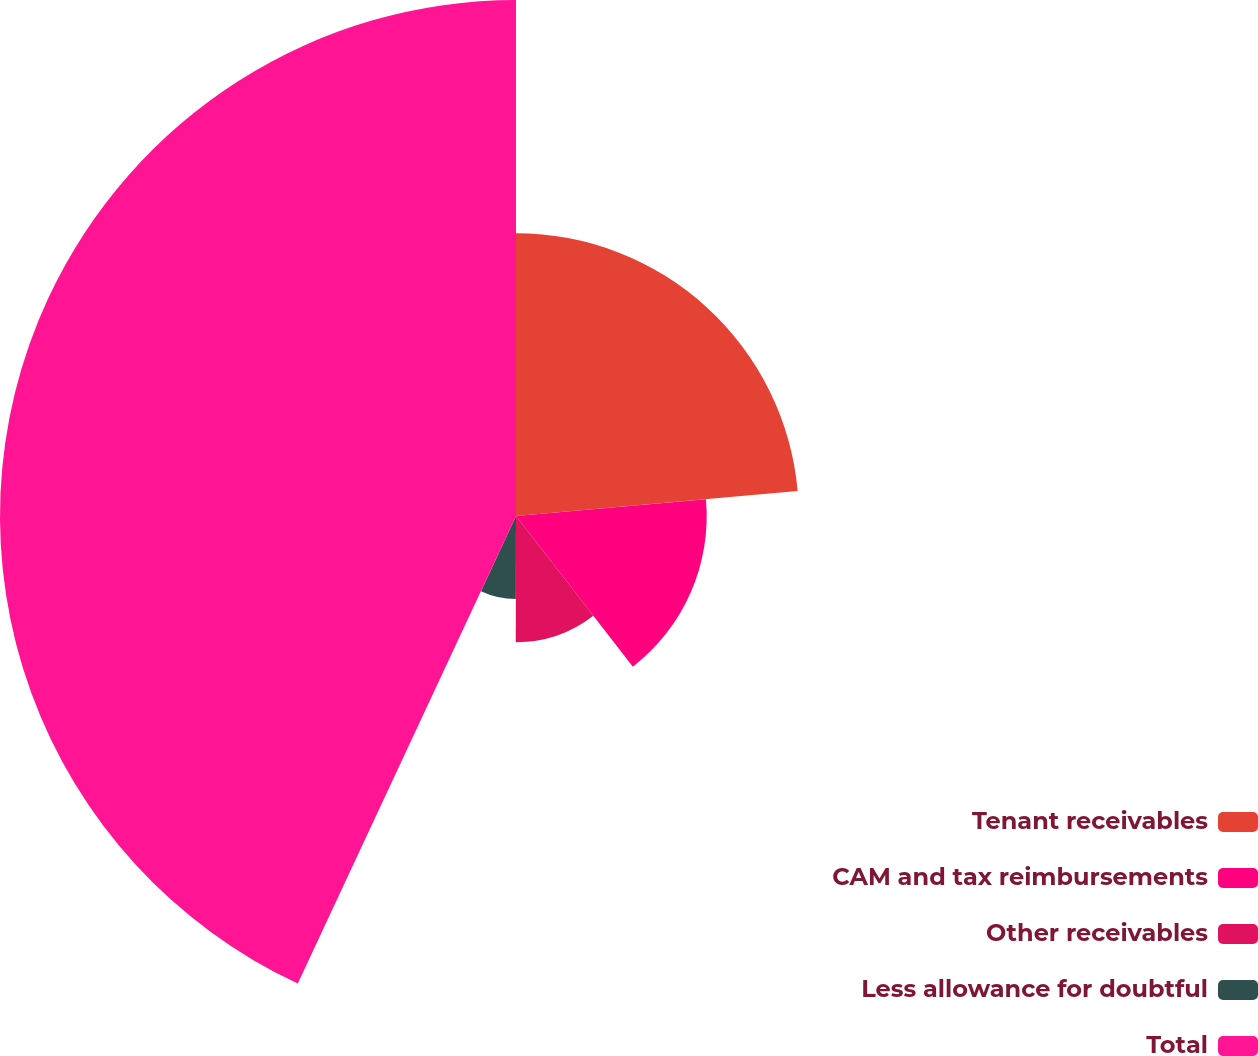Convert chart. <chart><loc_0><loc_0><loc_500><loc_500><pie_chart><fcel>Tenant receivables<fcel>CAM and tax reimbursements<fcel>Other receivables<fcel>Less allowance for doubtful<fcel>Total<nl><fcel>23.59%<fcel>15.91%<fcel>10.53%<fcel>6.92%<fcel>43.05%<nl></chart> 